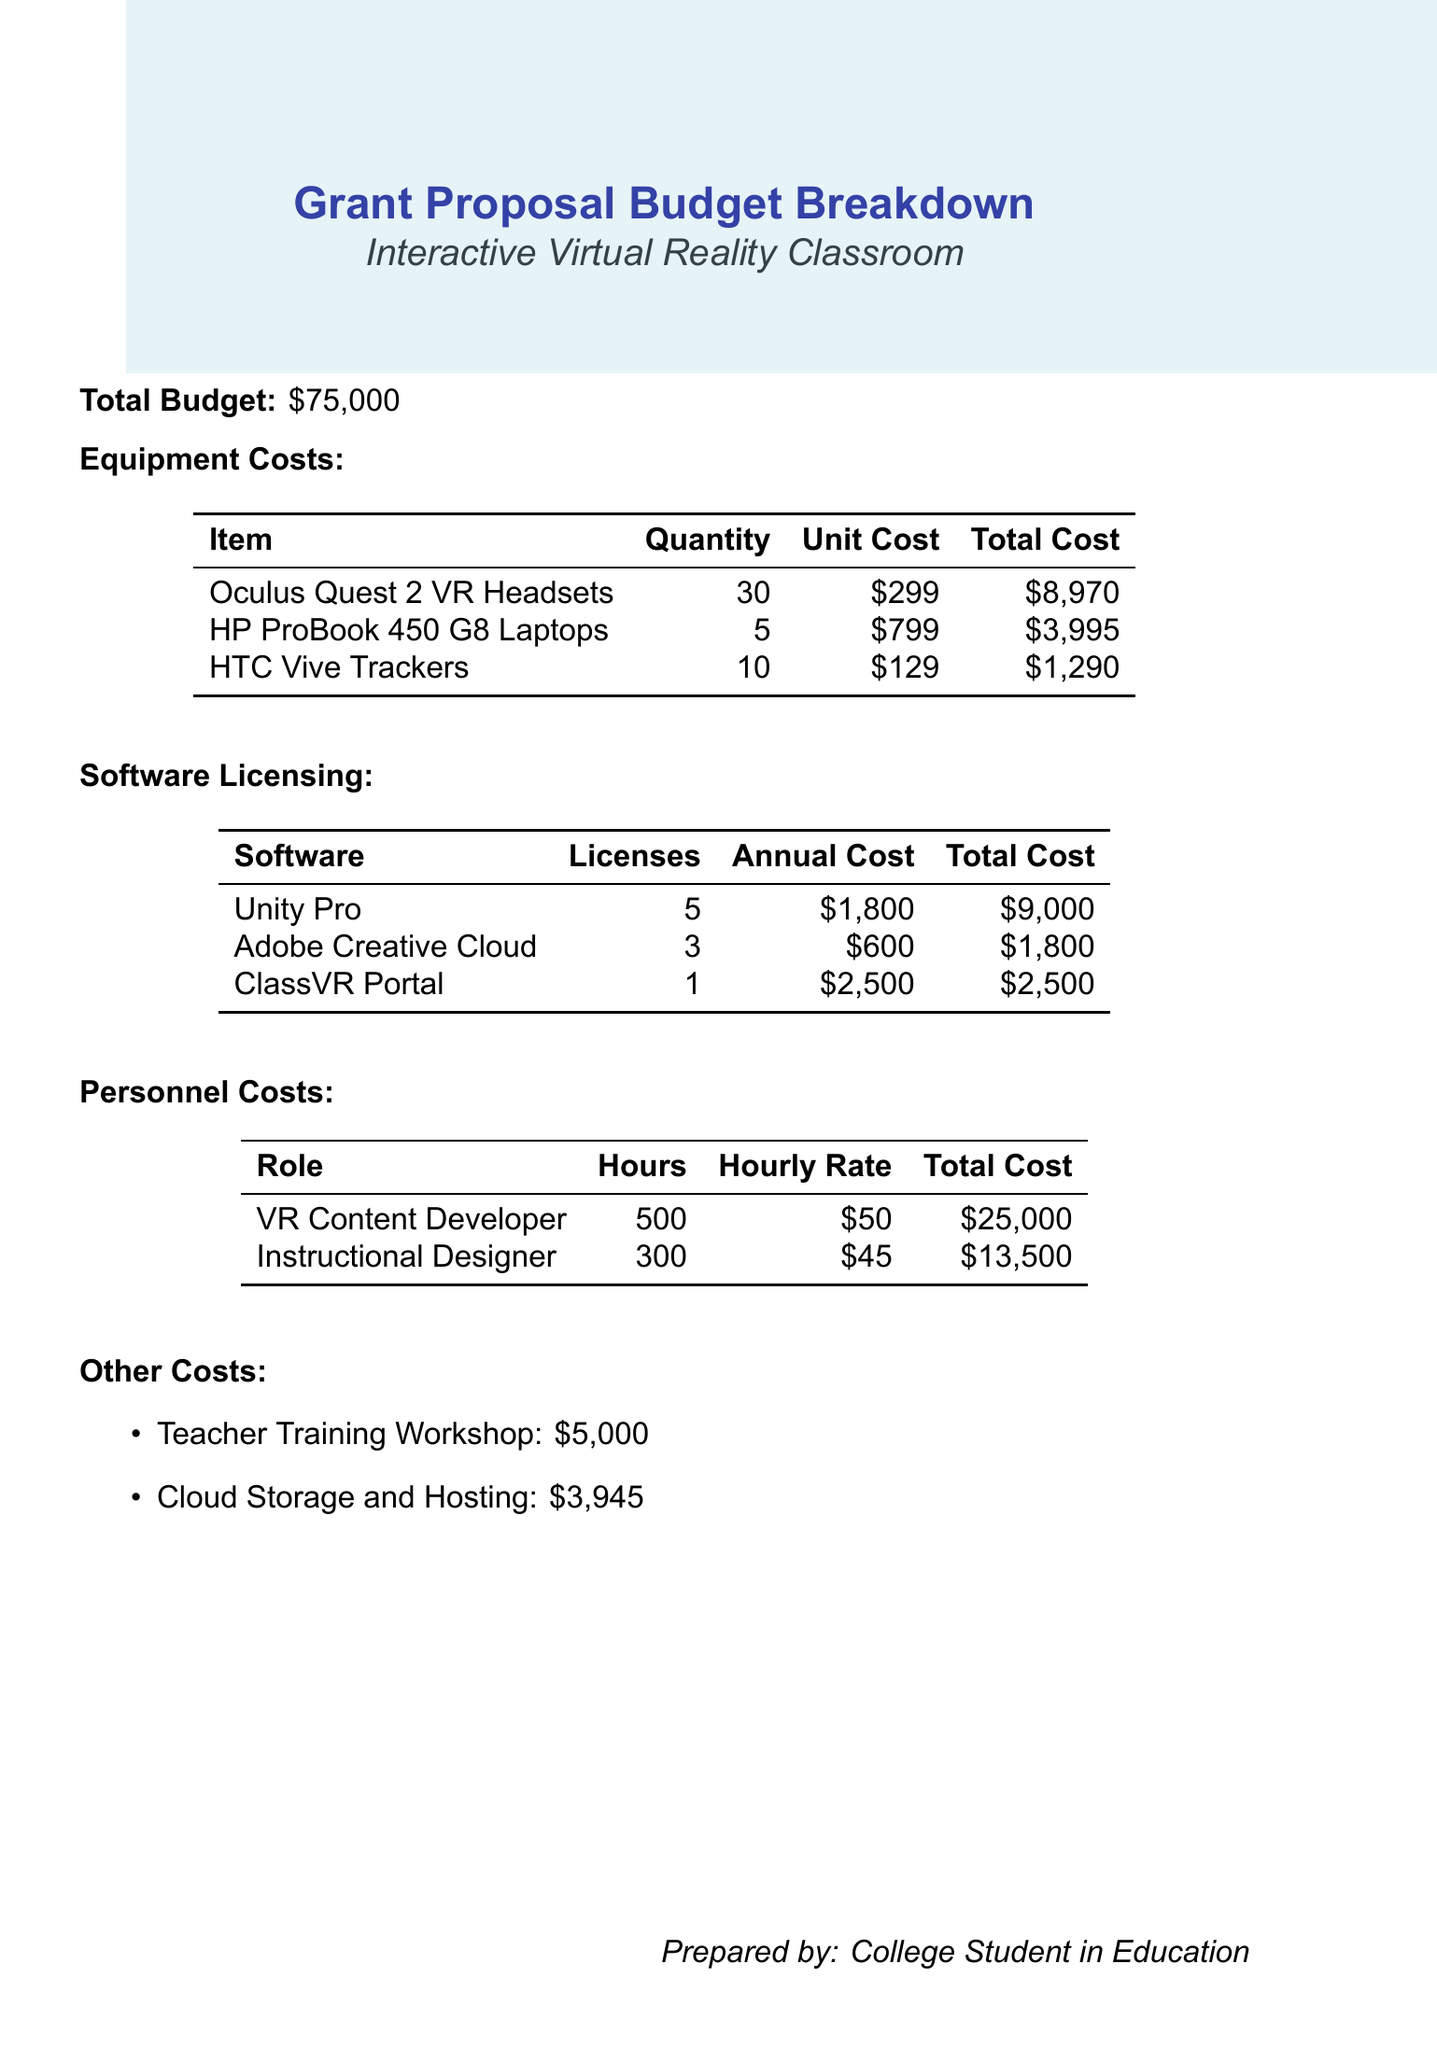What is the total budget for the project? The total budget is explicitly stated at the beginning of the document.
Answer: $75,000 How many Oculus Quest 2 VR Headsets are included in the equipment costs? The quantity of Oculus Quest 2 VR Headsets is listed in the equipment costs table.
Answer: 30 What is the total cost for the HP ProBook 450 G8 Laptops? The total cost for HP ProBook 450 G8 Laptops is provided in the equipment costs section.
Answer: $3,995 How much does a license for Unity Pro cost annually? The annual cost for a Unity Pro license is specified in the software licensing table.
Answer: $1,800 What is the hourly rate for the VR Content Developer? The hourly rate for the VR Content Developer is mentioned in the personnel costs section.
Answer: $50 What is the total personnel cost for both roles combined? The total personnel cost is the sum of the costs for both roles listed in the personnel costs table.
Answer: $38,500 What is the cost of the Teacher Training Workshop? The cost of the Teacher Training Workshop is listed under other costs.
Answer: $5,000 Which software has the highest total licensing cost? The total costs for software licensing are compared to find the one with the highest total.
Answer: Unity Pro How many teacher training workshops can be funded with the remaining budget after equipment costs? This requires calculating remaining budget after deducting equipment costs and then dividing by the cost of one teacher training workshop.
Answer: 5 